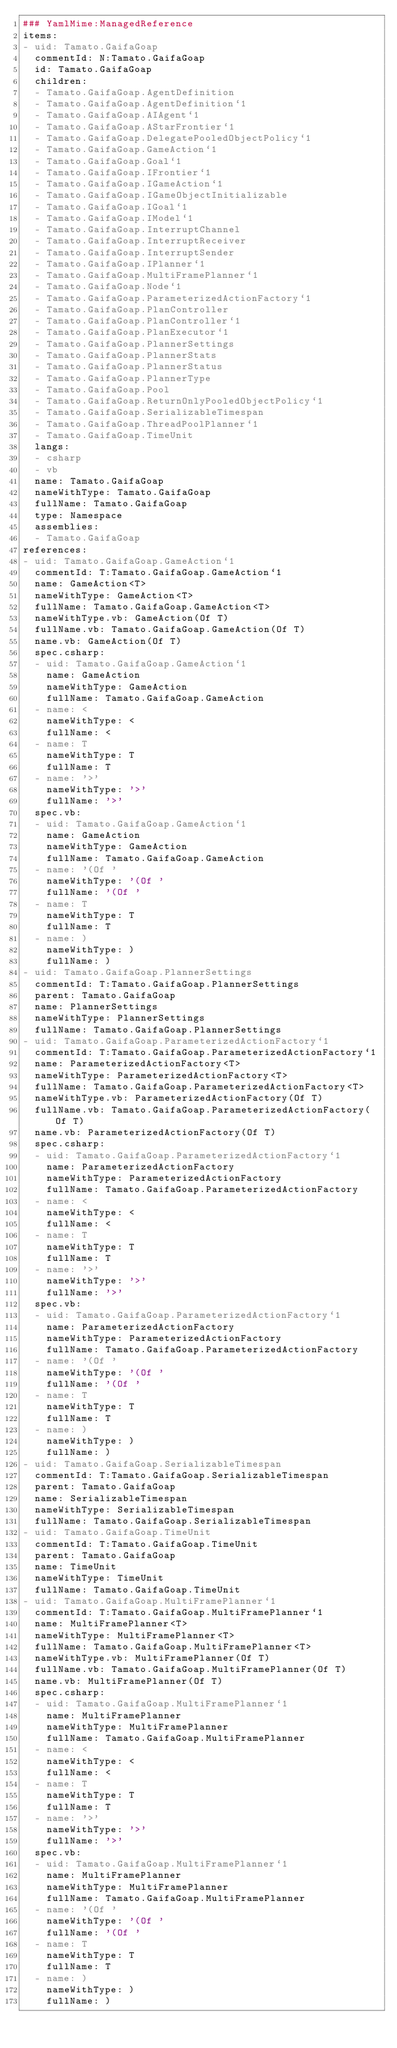<code> <loc_0><loc_0><loc_500><loc_500><_YAML_>### YamlMime:ManagedReference
items:
- uid: Tamato.GaifaGoap
  commentId: N:Tamato.GaifaGoap
  id: Tamato.GaifaGoap
  children:
  - Tamato.GaifaGoap.AgentDefinition
  - Tamato.GaifaGoap.AgentDefinition`1
  - Tamato.GaifaGoap.AIAgent`1
  - Tamato.GaifaGoap.AStarFrontier`1
  - Tamato.GaifaGoap.DelegatePooledObjectPolicy`1
  - Tamato.GaifaGoap.GameAction`1
  - Tamato.GaifaGoap.Goal`1
  - Tamato.GaifaGoap.IFrontier`1
  - Tamato.GaifaGoap.IGameAction`1
  - Tamato.GaifaGoap.IGameObjectInitializable
  - Tamato.GaifaGoap.IGoal`1
  - Tamato.GaifaGoap.IModel`1
  - Tamato.GaifaGoap.InterruptChannel
  - Tamato.GaifaGoap.InterruptReceiver
  - Tamato.GaifaGoap.InterruptSender
  - Tamato.GaifaGoap.IPlanner`1
  - Tamato.GaifaGoap.MultiFramePlanner`1
  - Tamato.GaifaGoap.Node`1
  - Tamato.GaifaGoap.ParameterizedActionFactory`1
  - Tamato.GaifaGoap.PlanController
  - Tamato.GaifaGoap.PlanController`1
  - Tamato.GaifaGoap.PlanExecutor`1
  - Tamato.GaifaGoap.PlannerSettings
  - Tamato.GaifaGoap.PlannerStats
  - Tamato.GaifaGoap.PlannerStatus
  - Tamato.GaifaGoap.PlannerType
  - Tamato.GaifaGoap.Pool
  - Tamato.GaifaGoap.ReturnOnlyPooledObjectPolicy`1
  - Tamato.GaifaGoap.SerializableTimespan
  - Tamato.GaifaGoap.ThreadPoolPlanner`1
  - Tamato.GaifaGoap.TimeUnit
  langs:
  - csharp
  - vb
  name: Tamato.GaifaGoap
  nameWithType: Tamato.GaifaGoap
  fullName: Tamato.GaifaGoap
  type: Namespace
  assemblies:
  - Tamato.GaifaGoap
references:
- uid: Tamato.GaifaGoap.GameAction`1
  commentId: T:Tamato.GaifaGoap.GameAction`1
  name: GameAction<T>
  nameWithType: GameAction<T>
  fullName: Tamato.GaifaGoap.GameAction<T>
  nameWithType.vb: GameAction(Of T)
  fullName.vb: Tamato.GaifaGoap.GameAction(Of T)
  name.vb: GameAction(Of T)
  spec.csharp:
  - uid: Tamato.GaifaGoap.GameAction`1
    name: GameAction
    nameWithType: GameAction
    fullName: Tamato.GaifaGoap.GameAction
  - name: <
    nameWithType: <
    fullName: <
  - name: T
    nameWithType: T
    fullName: T
  - name: '>'
    nameWithType: '>'
    fullName: '>'
  spec.vb:
  - uid: Tamato.GaifaGoap.GameAction`1
    name: GameAction
    nameWithType: GameAction
    fullName: Tamato.GaifaGoap.GameAction
  - name: '(Of '
    nameWithType: '(Of '
    fullName: '(Of '
  - name: T
    nameWithType: T
    fullName: T
  - name: )
    nameWithType: )
    fullName: )
- uid: Tamato.GaifaGoap.PlannerSettings
  commentId: T:Tamato.GaifaGoap.PlannerSettings
  parent: Tamato.GaifaGoap
  name: PlannerSettings
  nameWithType: PlannerSettings
  fullName: Tamato.GaifaGoap.PlannerSettings
- uid: Tamato.GaifaGoap.ParameterizedActionFactory`1
  commentId: T:Tamato.GaifaGoap.ParameterizedActionFactory`1
  name: ParameterizedActionFactory<T>
  nameWithType: ParameterizedActionFactory<T>
  fullName: Tamato.GaifaGoap.ParameterizedActionFactory<T>
  nameWithType.vb: ParameterizedActionFactory(Of T)
  fullName.vb: Tamato.GaifaGoap.ParameterizedActionFactory(Of T)
  name.vb: ParameterizedActionFactory(Of T)
  spec.csharp:
  - uid: Tamato.GaifaGoap.ParameterizedActionFactory`1
    name: ParameterizedActionFactory
    nameWithType: ParameterizedActionFactory
    fullName: Tamato.GaifaGoap.ParameterizedActionFactory
  - name: <
    nameWithType: <
    fullName: <
  - name: T
    nameWithType: T
    fullName: T
  - name: '>'
    nameWithType: '>'
    fullName: '>'
  spec.vb:
  - uid: Tamato.GaifaGoap.ParameterizedActionFactory`1
    name: ParameterizedActionFactory
    nameWithType: ParameterizedActionFactory
    fullName: Tamato.GaifaGoap.ParameterizedActionFactory
  - name: '(Of '
    nameWithType: '(Of '
    fullName: '(Of '
  - name: T
    nameWithType: T
    fullName: T
  - name: )
    nameWithType: )
    fullName: )
- uid: Tamato.GaifaGoap.SerializableTimespan
  commentId: T:Tamato.GaifaGoap.SerializableTimespan
  parent: Tamato.GaifaGoap
  name: SerializableTimespan
  nameWithType: SerializableTimespan
  fullName: Tamato.GaifaGoap.SerializableTimespan
- uid: Tamato.GaifaGoap.TimeUnit
  commentId: T:Tamato.GaifaGoap.TimeUnit
  parent: Tamato.GaifaGoap
  name: TimeUnit
  nameWithType: TimeUnit
  fullName: Tamato.GaifaGoap.TimeUnit
- uid: Tamato.GaifaGoap.MultiFramePlanner`1
  commentId: T:Tamato.GaifaGoap.MultiFramePlanner`1
  name: MultiFramePlanner<T>
  nameWithType: MultiFramePlanner<T>
  fullName: Tamato.GaifaGoap.MultiFramePlanner<T>
  nameWithType.vb: MultiFramePlanner(Of T)
  fullName.vb: Tamato.GaifaGoap.MultiFramePlanner(Of T)
  name.vb: MultiFramePlanner(Of T)
  spec.csharp:
  - uid: Tamato.GaifaGoap.MultiFramePlanner`1
    name: MultiFramePlanner
    nameWithType: MultiFramePlanner
    fullName: Tamato.GaifaGoap.MultiFramePlanner
  - name: <
    nameWithType: <
    fullName: <
  - name: T
    nameWithType: T
    fullName: T
  - name: '>'
    nameWithType: '>'
    fullName: '>'
  spec.vb:
  - uid: Tamato.GaifaGoap.MultiFramePlanner`1
    name: MultiFramePlanner
    nameWithType: MultiFramePlanner
    fullName: Tamato.GaifaGoap.MultiFramePlanner
  - name: '(Of '
    nameWithType: '(Of '
    fullName: '(Of '
  - name: T
    nameWithType: T
    fullName: T
  - name: )
    nameWithType: )
    fullName: )</code> 